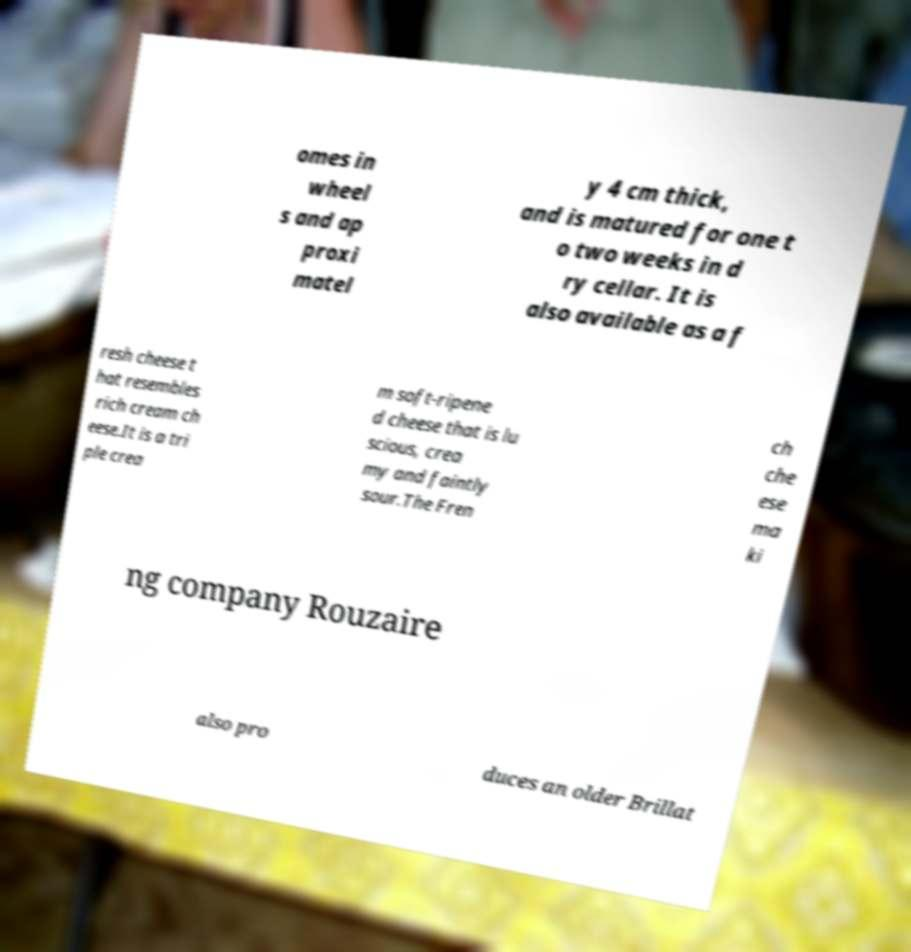Could you assist in decoding the text presented in this image and type it out clearly? omes in wheel s and ap proxi matel y 4 cm thick, and is matured for one t o two weeks in d ry cellar. It is also available as a f resh cheese t hat resembles rich cream ch eese.It is a tri ple crea m soft-ripene d cheese that is lu scious, crea my and faintly sour.The Fren ch che ese ma ki ng company Rouzaire also pro duces an older Brillat 